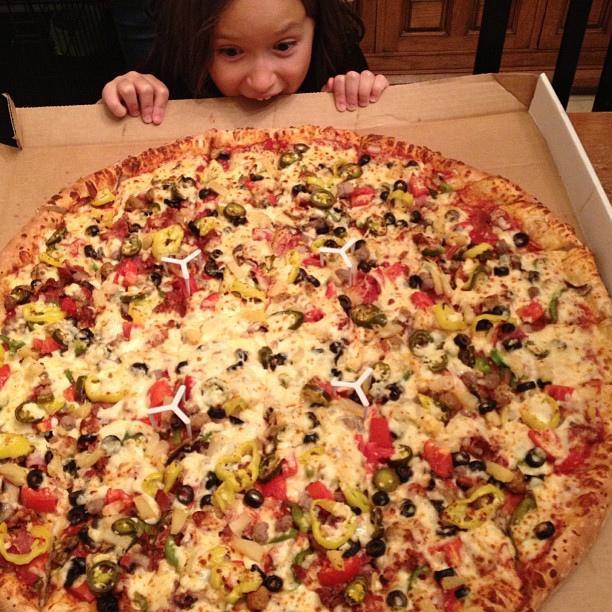Is "The person is touching the pizza." an appropriate description for the image?
Answer yes or no. No. 